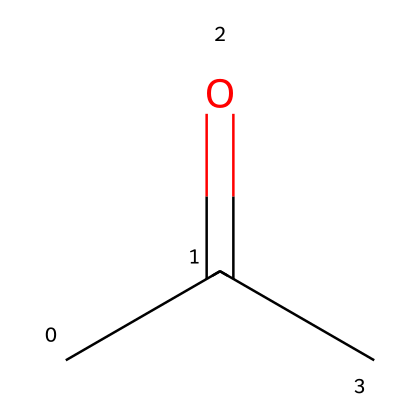What is the name of this chemical? The chemical represented by the SMILES CC(=O)C is acetone, which is a well-known solvent commonly used in nail polish remover.
Answer: acetone How many carbon atoms are in the structure? The SMILES representation CC(=O)C indicates that there are three carbon atoms present in the molecule. They are represented by the 'C' characters.
Answer: three What type of functional group does this compound contain? The SMILES shows a carbonyl group (C=O) indicated by the 'C(=O)' part, which classifies this compound as a ketone.
Answer: ketone How many hydrogen atoms are bonded to carbon? Based on the structure, the two end carbon atoms are bonded to three hydrogen atoms, and the middle carbon atom has one hydrogen atom, totaling seven hydrogen atoms.
Answer: seven What is the degree of saturation of acetone? The structure has a carbonyl group, indicating one degree of unsaturation, implying that there are three carbons with one double bond reducing the saturation. This results in a total of two degrees of saturation.
Answer: two What type of reaction would acetone undergo to form another structure? Acetone can undergo oxidation reactions, specifically to generate larger carboxylic acids from its structural makeup, as it contains a functional carbonyl group.
Answer: oxidation 